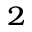Convert formula to latex. <formula><loc_0><loc_0><loc_500><loc_500>^ { 2 }</formula> 